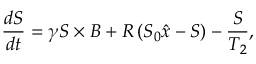Convert formula to latex. <formula><loc_0><loc_0><loc_500><loc_500>\frac { d S } { d t } = \gamma S \times B + R \left ( S _ { 0 } \hat { x } - S \right ) - \frac { S } { T _ { 2 } } ,</formula> 